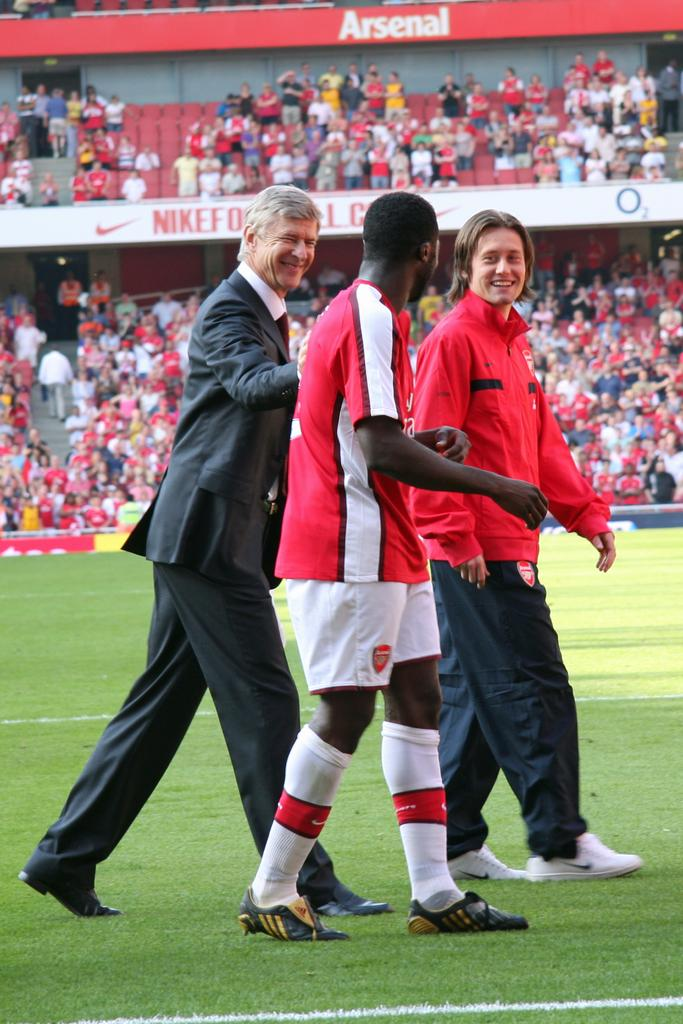How many people are on the ground in the image? There are three persons on the ground in the image. What can be seen in the background of the image? There is a fence and a crowd in the background of the image. What type of structure is visible in the background? There are boards in the stadium in the background of the image. When was the image taken? The image was taken during the day. What type of mine is visible in the image? There is no mine present in the image. What kind of pets can be seen accompanying the persons on the ground? There are no pets visible in the image; only three persons are present on the ground. 